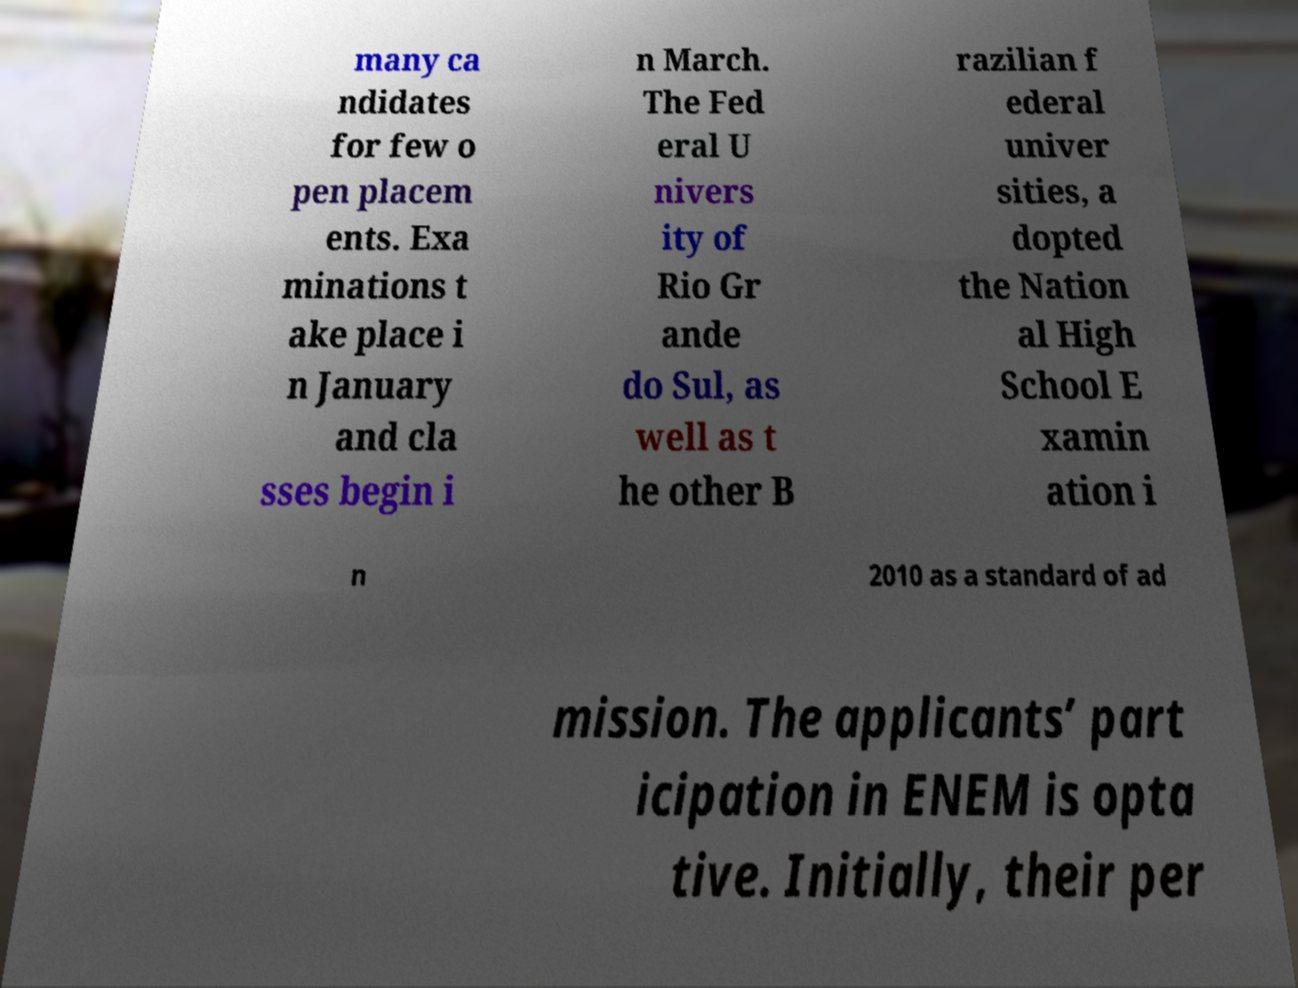What messages or text are displayed in this image? I need them in a readable, typed format. many ca ndidates for few o pen placem ents. Exa minations t ake place i n January and cla sses begin i n March. The Fed eral U nivers ity of Rio Gr ande do Sul, as well as t he other B razilian f ederal univer sities, a dopted the Nation al High School E xamin ation i n 2010 as a standard of ad mission. The applicants’ part icipation in ENEM is opta tive. Initially, their per 